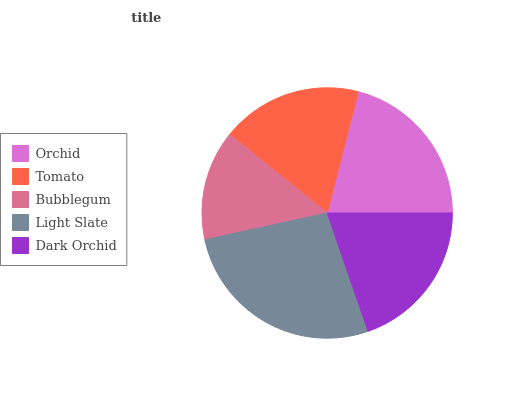Is Bubblegum the minimum?
Answer yes or no. Yes. Is Light Slate the maximum?
Answer yes or no. Yes. Is Tomato the minimum?
Answer yes or no. No. Is Tomato the maximum?
Answer yes or no. No. Is Orchid greater than Tomato?
Answer yes or no. Yes. Is Tomato less than Orchid?
Answer yes or no. Yes. Is Tomato greater than Orchid?
Answer yes or no. No. Is Orchid less than Tomato?
Answer yes or no. No. Is Dark Orchid the high median?
Answer yes or no. Yes. Is Dark Orchid the low median?
Answer yes or no. Yes. Is Orchid the high median?
Answer yes or no. No. Is Tomato the low median?
Answer yes or no. No. 